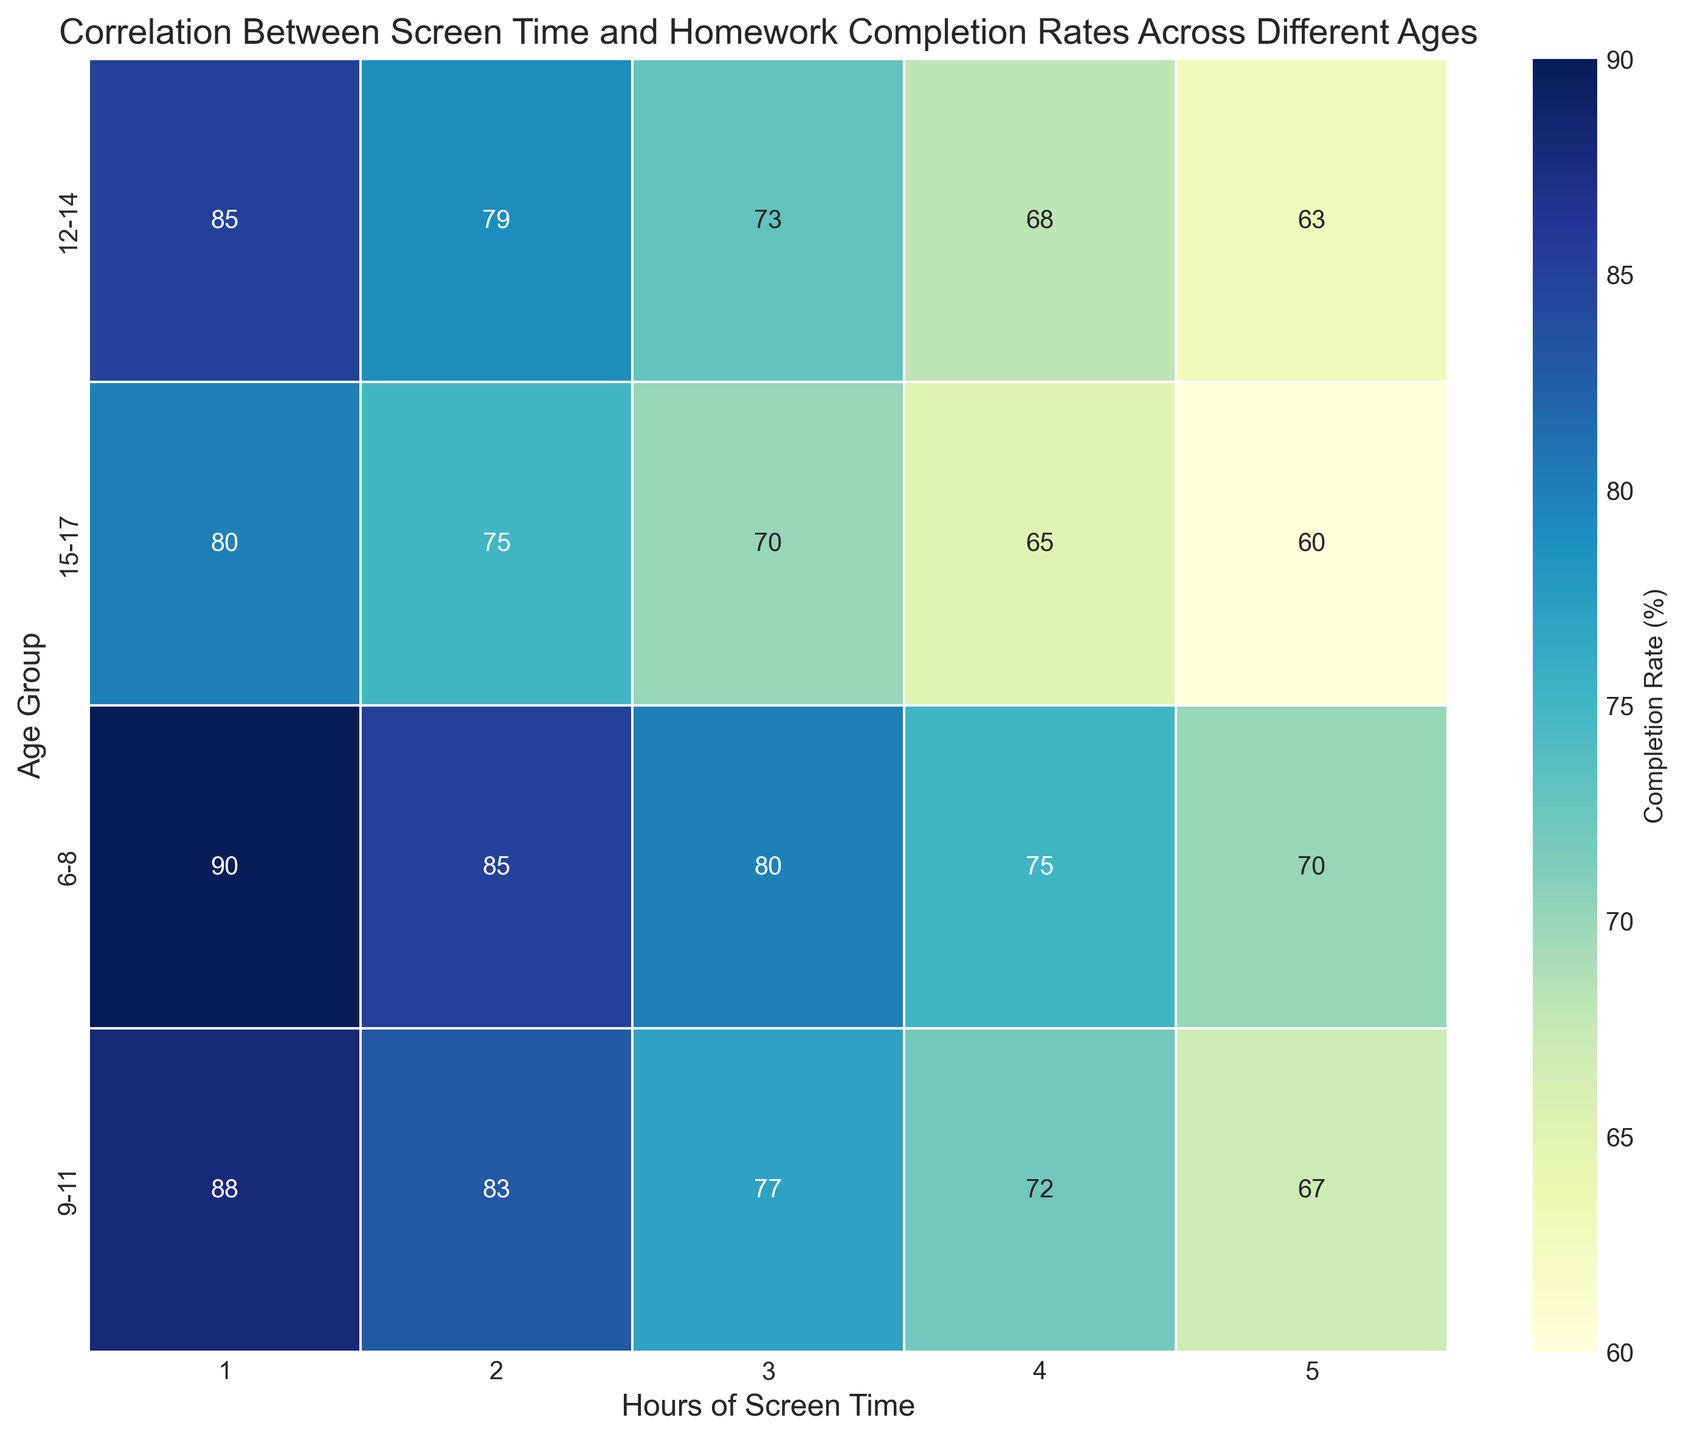What is the overall trend in homework completion rates as hours of screen time increase across all age groups? As the hours of screen time increase, the homework completion rates for all age groups decrease. This trend can be seen by observing the color changes in the heatmap, which shift from darker blue (higher completion rates) to lighter blue/yellow as screen time increases.
Answer: Decreasing Which age group has the highest homework completion rate with 3 hours of screen time? Look at the column labeled '3 Hours of Screen Time' in the heatmap and compare the values for all age groups. The age group 6-8 has the highest homework completion rate at 80%.
Answer: 6-8 Compare the homework completion rates of the 9-11 and 15-17 age groups with 2 hours of screen time. Which group has the higher rate? Examine the '2 Hours of Screen Time' column in the heatmap. The rate for the 9-11 age group is 83%, while for the 15-17 age group, it is 75%. Therefore, the 9-11 age group has the higher rate.
Answer: 9-11 How does the homework completion rate for the 12-14 age group change from 1 hour to 5 hours of screen time? Check the row for the 12-14 age group. The homework completion rate starts at 85% with 1 hour of screen time and decreases progressively to 63% with 5 hours of screen time.
Answer: Decreases from 85% to 63% What is the average homework completion rate for the 15-17 age group across all screen time hours? The completion rates for 15-17 are 80, 75, 70, 65, and 60 for screen times of 1, 2, 3, 4, and 5 hours respectively. Calculate the average: (80+75+70+65+60)/5 = 70%.
Answer: 70% Which age group sees the greatest absolute decrease in homework completion rate from 1 to 5 hours of screen time? Calculate the difference between the homework completion rate at 1 hour and 5 hours for each age group. The decreases are: 6-8: 90-70=20; 9-11: 88-67=21; 12-14: 85-63=22; 15-17: 80-60=20. The 12-14 age group has the greatest absolute decrease of 22 percentage points.
Answer: 12-14 Between the 6-8 age group and the 12-14 age group, which has a higher average homework completion rate for screen time hours of 2, 3, and 4? Calculate the average for both age groups for 2, 3, and 4 hours of screen time. For the 6-8 age group: (85+80+75)/3 = 80%. For the 12-14 age group: (79+73+68)/3 ≈ 73.33%. The 6-8 age group has the higher average.
Answer: 6-8 What is the difference in homework completion rates between 1 hour and 2 hours of screen time for the 9-11 age group? Look at the completion rates for 1 hour (88%) and 2 hours (83%) of screen time for the 9-11 age group. The difference is 88% - 83% = 5 percentage points.
Answer: 5 percentage points 